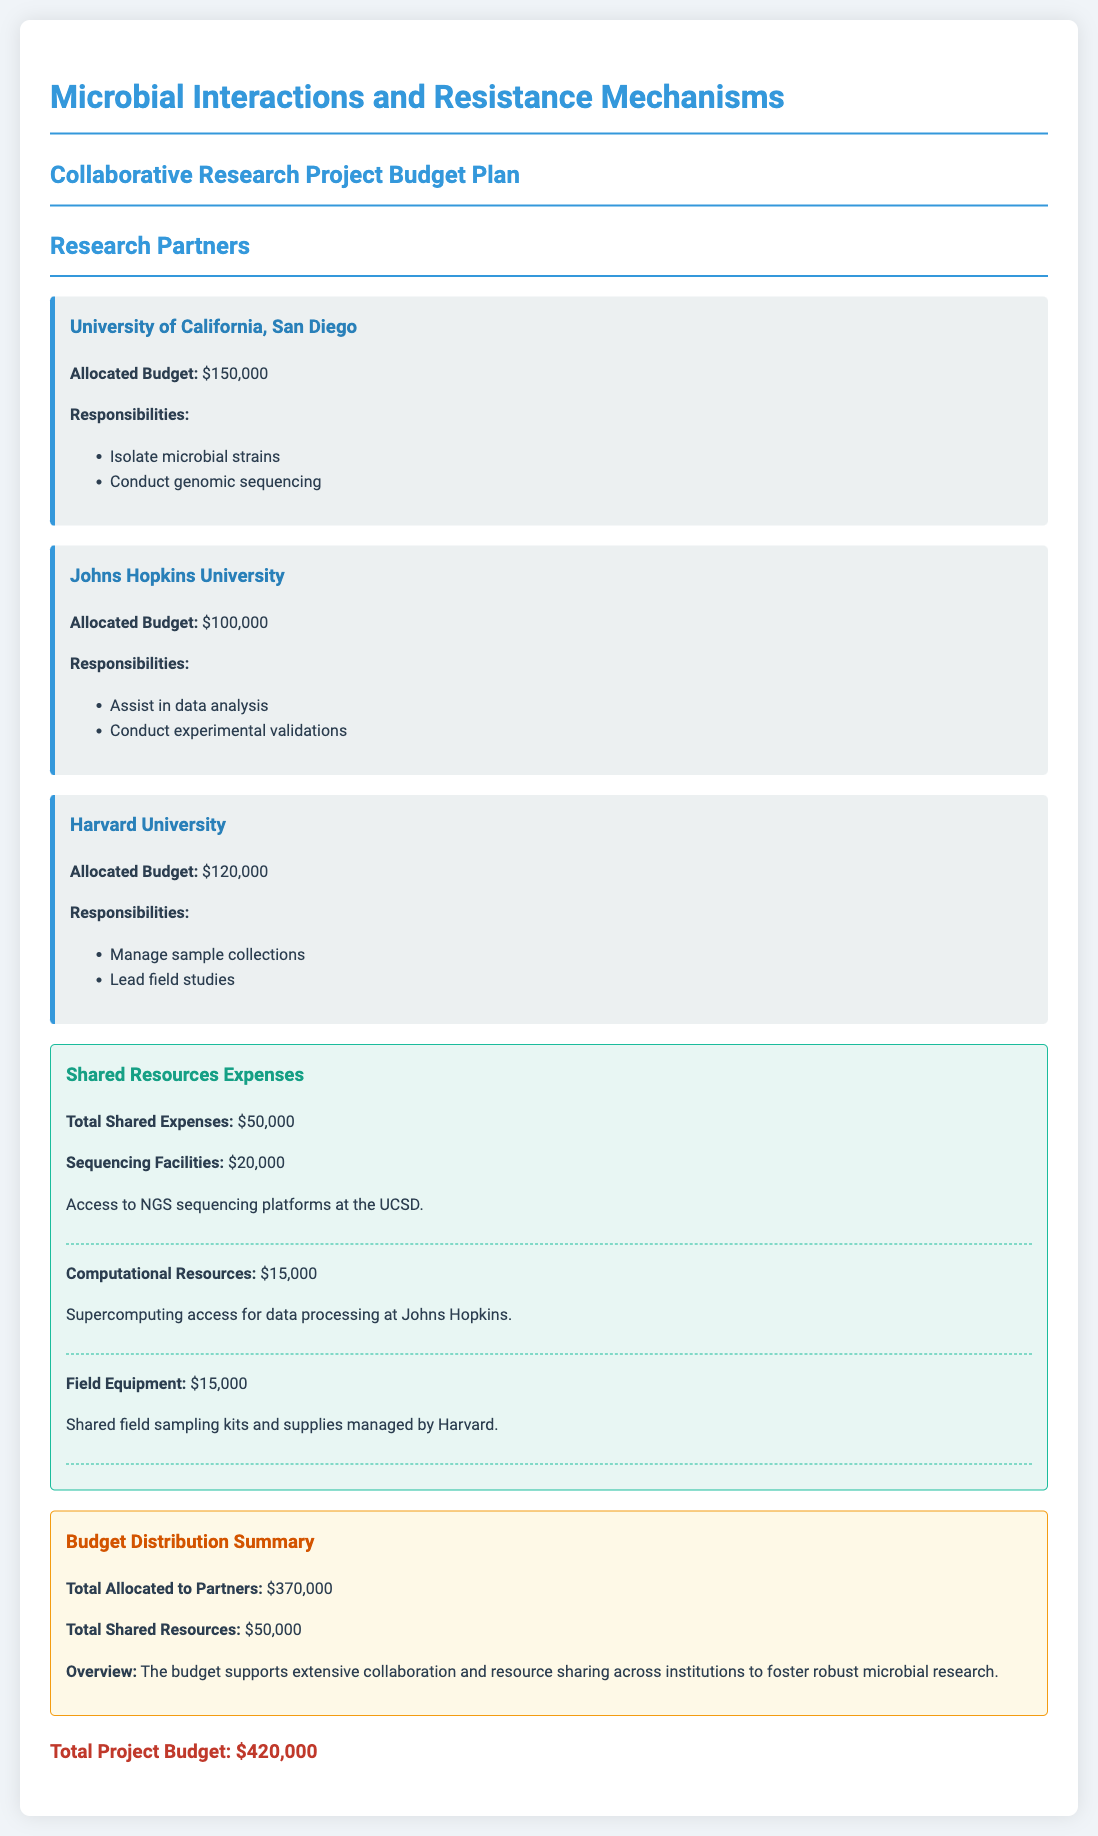What is the total budget allocated to Harvard University? The allocated budget for Harvard University is specified in the document as $120,000.
Answer: $120,000 What are the responsibilities of Johns Hopkins University? The responsibilities listed for Johns Hopkins University include assisting in data analysis and conducting experimental validations.
Answer: Assist in data analysis, conduct experimental validations What is the total budget for shared resources? The document states that the total shared expenses amount to $50,000.
Answer: $50,000 Which institution manages sample collections? The document specifies that Harvard University is responsible for managing sample collections.
Answer: Harvard University How much is allocated to sequencing facilities? The budget for sequencing facilities is detailed in the document as $20,000.
Answer: $20,000 What is the total allocated budget for all partners? The total allocated budget for all partners combined is mentioned as $370,000 in the summary.
Answer: $370,000 Which university has the highest budget allocation? The document indicates that University of California, San Diego has the highest budget allocation of $150,000.
Answer: University of California, San Diego What type of resources are mentioned in the shared resources section? The shared resources section includes sequencing facilities, computational resources, and field equipment.
Answer: Sequencing facilities, computational resources, field equipment What is the total project budget? The total project budget is clearly stated in the document as $420,000.
Answer: $420,000 